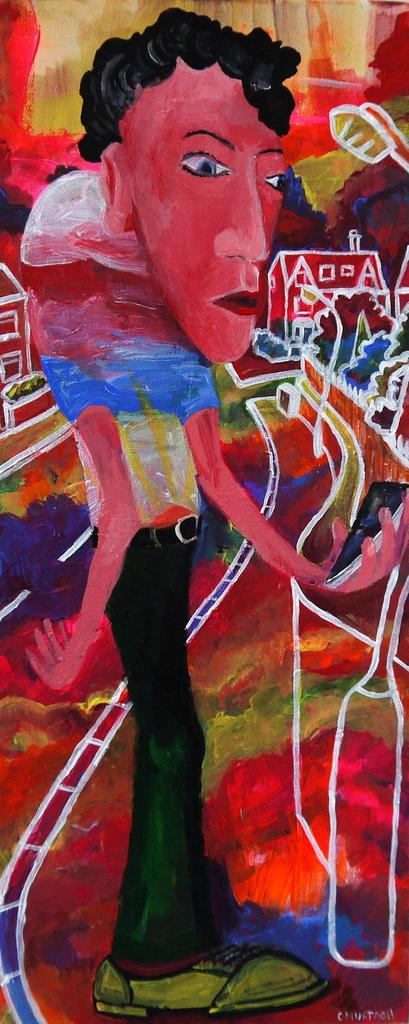What is the main subject of the image? There is a painting in the image. What does the painting depict? The painting depicts a person and houses. Are there any other elements in the painting besides the person and houses? Yes, there are other unspecified things in the painting. What type of design does the mom use to decorate the top of the painting? There is no mention of a mom or a design in the image, and the painting is not described as having a top. 